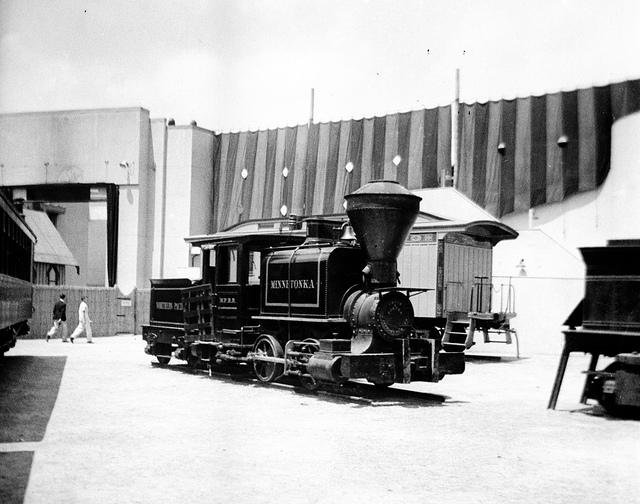How many people are there?
Concise answer only. 2. Is there a train in the picture?
Keep it brief. Yes. Is this photo in black and white?
Be succinct. Yes. 